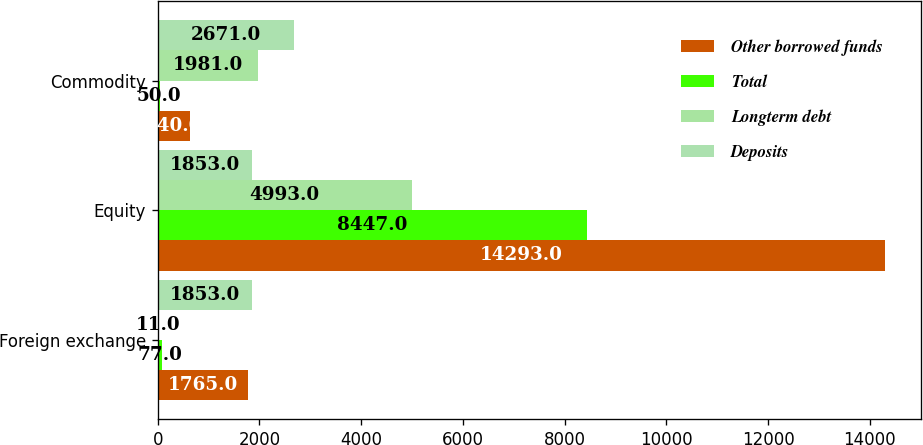Convert chart to OTSL. <chart><loc_0><loc_0><loc_500><loc_500><stacked_bar_chart><ecel><fcel>Foreign exchange<fcel>Equity<fcel>Commodity<nl><fcel>Other borrowed funds<fcel>1765<fcel>14293<fcel>640<nl><fcel>Total<fcel>77<fcel>8447<fcel>50<nl><fcel>Longterm debt<fcel>11<fcel>4993<fcel>1981<nl><fcel>Deposits<fcel>1853<fcel>1853<fcel>2671<nl></chart> 